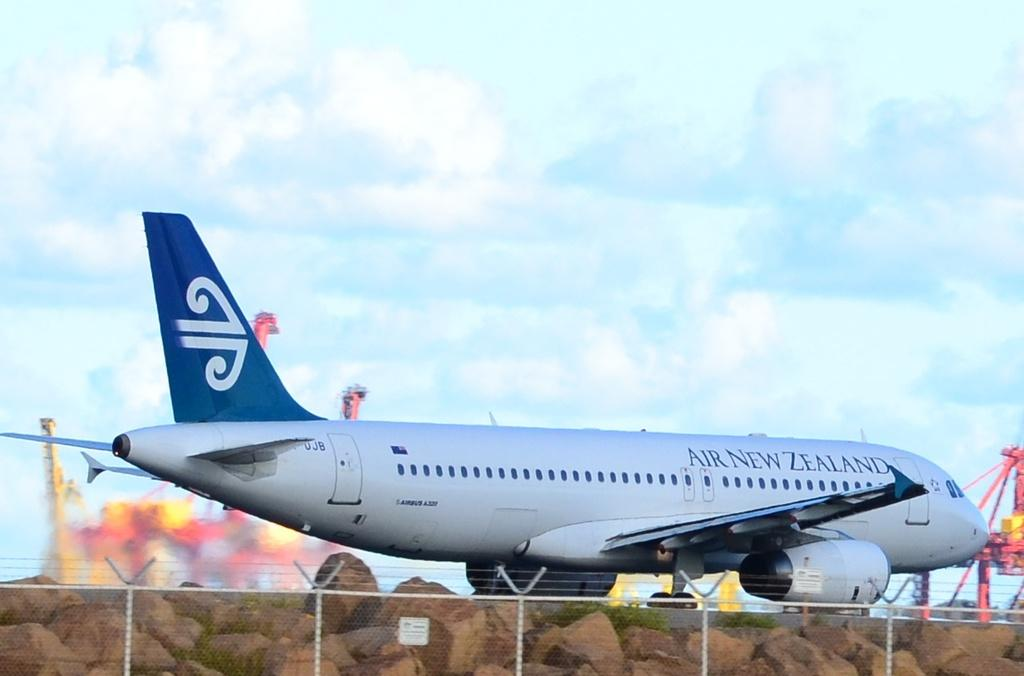What type of structure can be seen in the image? There is fencing in the image. What is attached to the fencing? There is a white color board on the fencing. What can be seen in the background of the image? There is a white color airplane, poles, clouds, and the sky visible in the background. What type of drum is being played by the team in the image? There is no drum or team present in the image. 